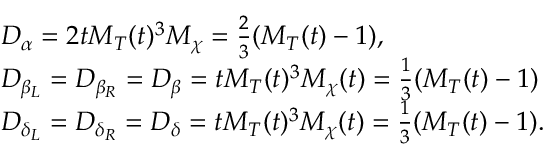Convert formula to latex. <formula><loc_0><loc_0><loc_500><loc_500>\begin{array} { r l } & { D _ { \alpha } = 2 t M _ { T } ( t ) ^ { 3 } M _ { \chi } = \frac { 2 } { 3 } ( M _ { T } ( t ) - 1 ) , } \\ & { D _ { \beta _ { L } } = D _ { \beta _ { R } } = D _ { \beta } = t M _ { T } ( t ) ^ { 3 } M _ { \chi } ( t ) = \frac { 1 } { 3 } ( M _ { T } ( t ) - 1 ) } \\ & { D _ { \delta _ { L } } = D _ { \delta _ { R } } = D _ { \delta } = t M _ { T } ( t ) ^ { 3 } M _ { \chi } ( t ) = \frac { 1 } { 3 } ( M _ { T } ( t ) - 1 ) . } \end{array}</formula> 